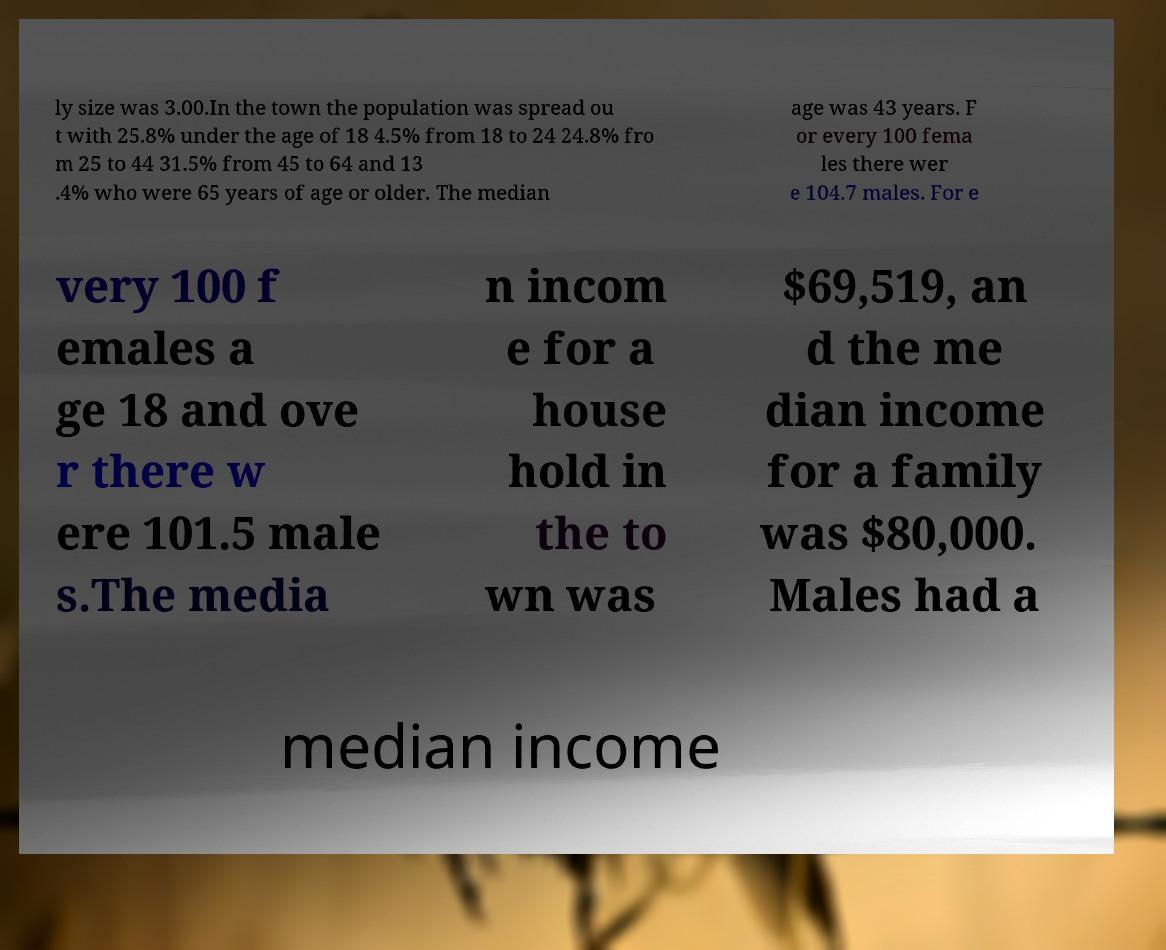I need the written content from this picture converted into text. Can you do that? ly size was 3.00.In the town the population was spread ou t with 25.8% under the age of 18 4.5% from 18 to 24 24.8% fro m 25 to 44 31.5% from 45 to 64 and 13 .4% who were 65 years of age or older. The median age was 43 years. F or every 100 fema les there wer e 104.7 males. For e very 100 f emales a ge 18 and ove r there w ere 101.5 male s.The media n incom e for a house hold in the to wn was $69,519, an d the me dian income for a family was $80,000. Males had a median income 